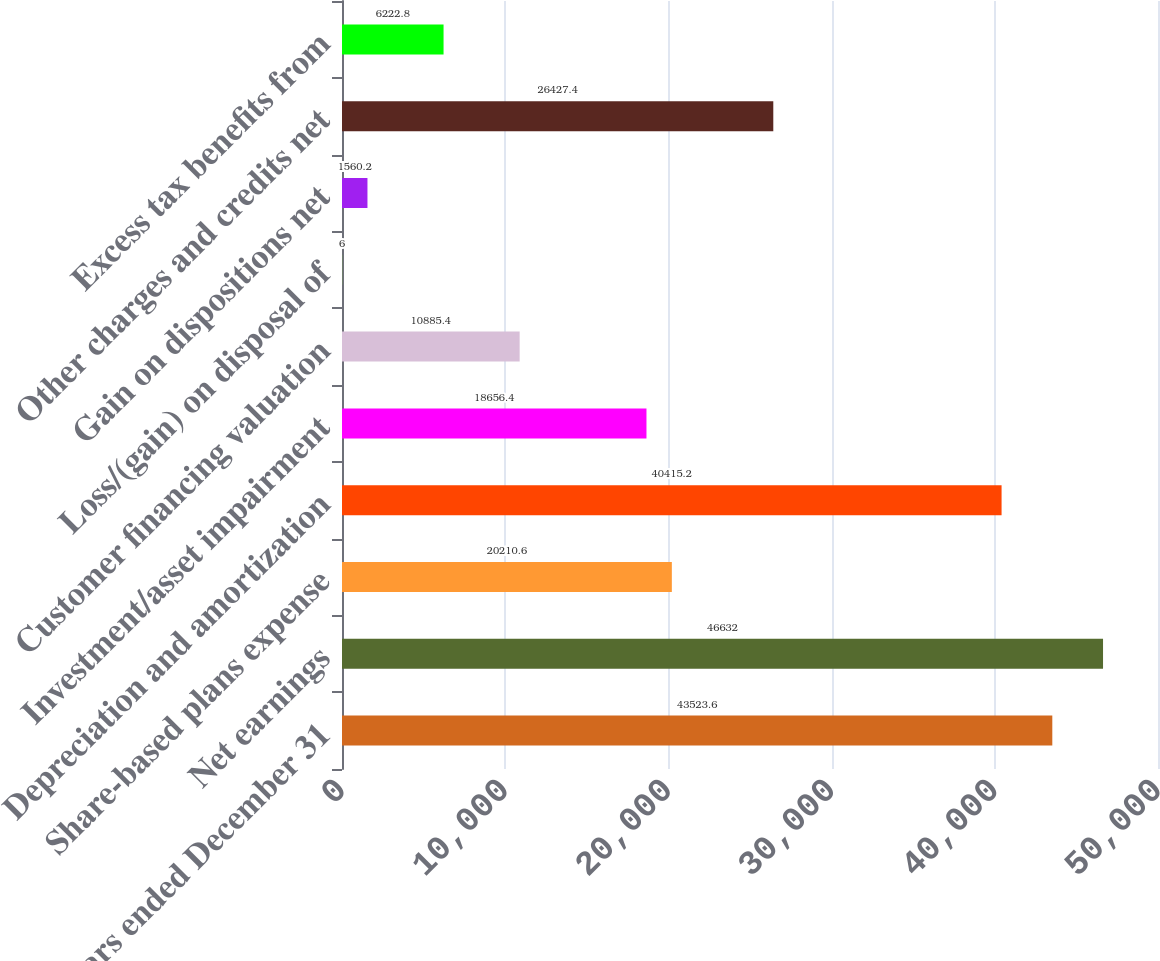<chart> <loc_0><loc_0><loc_500><loc_500><bar_chart><fcel>Years ended December 31<fcel>Net earnings<fcel>Share-based plans expense<fcel>Depreciation and amortization<fcel>Investment/asset impairment<fcel>Customer financing valuation<fcel>Loss/(gain) on disposal of<fcel>Gain on dispositions net<fcel>Other charges and credits net<fcel>Excess tax benefits from<nl><fcel>43523.6<fcel>46632<fcel>20210.6<fcel>40415.2<fcel>18656.4<fcel>10885.4<fcel>6<fcel>1560.2<fcel>26427.4<fcel>6222.8<nl></chart> 